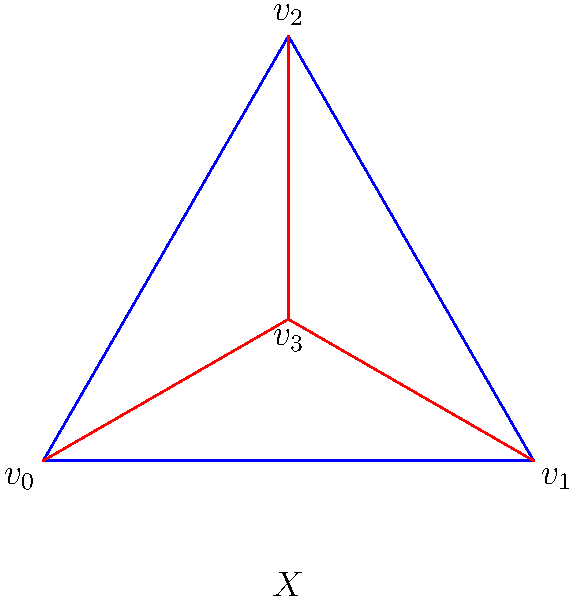Consider the simplicial complex $X$ representing the preservation efforts of historical sites in Belarus. The complex consists of a triangle with an additional vertex connected to all three vertices of the triangle, as shown in the figure. Calculate the first homology group $H_1(X)$ of this complex. To calculate the first homology group $H_1(X)$, we'll follow these steps:

1) First, let's count the simplices in each dimension:
   0-simplices (vertices): 4 ($v_0$, $v_1$, $v_2$, $v_3$)
   1-simplices (edges): 6 ($v_0v_1$, $v_1v_2$, $v_2v_0$, $v_0v_3$, $v_1v_3$, $v_2v_3$)
   2-simplices (triangles): 4 ($v_0v_1v_2$, $v_0v_1v_3$, $v_1v_2v_3$, $v_0v_2v_3$)

2) Now, let's construct the chain complex:
   $C_2 \xrightarrow{\partial_2} C_1 \xrightarrow{\partial_1} C_0$

3) The boundary maps are:
   $\partial_2: \mathbb{Z}^4 \to \mathbb{Z}^6$
   $\partial_1: \mathbb{Z}^6 \to \mathbb{Z}^4$

4) We need to find $\ker(\partial_1)$ and $\text{im}(\partial_2)$:
   
   $\ker(\partial_1)$ represents cycles, which are closed loops in the complex.
   $\text{im}(\partial_2)$ represents boundaries, which are cycles that bound a 2-dimensional region.

5) In this complex, there are three independent cycles:
   - The outer triangle ($v_0v_1v_2$)
   - Any two of the three triangles formed with $v_3$

   However, all of these cycles are boundaries of 2-simplices.

6) Therefore, $\ker(\partial_1) = \text{im}(\partial_2)$

7) The first homology group is defined as:
   $H_1(X) = \ker(\partial_1) / \text{im}(\partial_2)$

8) Since $\ker(\partial_1) = \text{im}(\partial_2)$, we have:
   $H_1(X) = \{0\}$, the trivial group.

This result indicates that there are no "holes" in the complex, reflecting a well-connected preservation effort for historical sites in Belarus.
Answer: $H_1(X) = \{0\}$ 